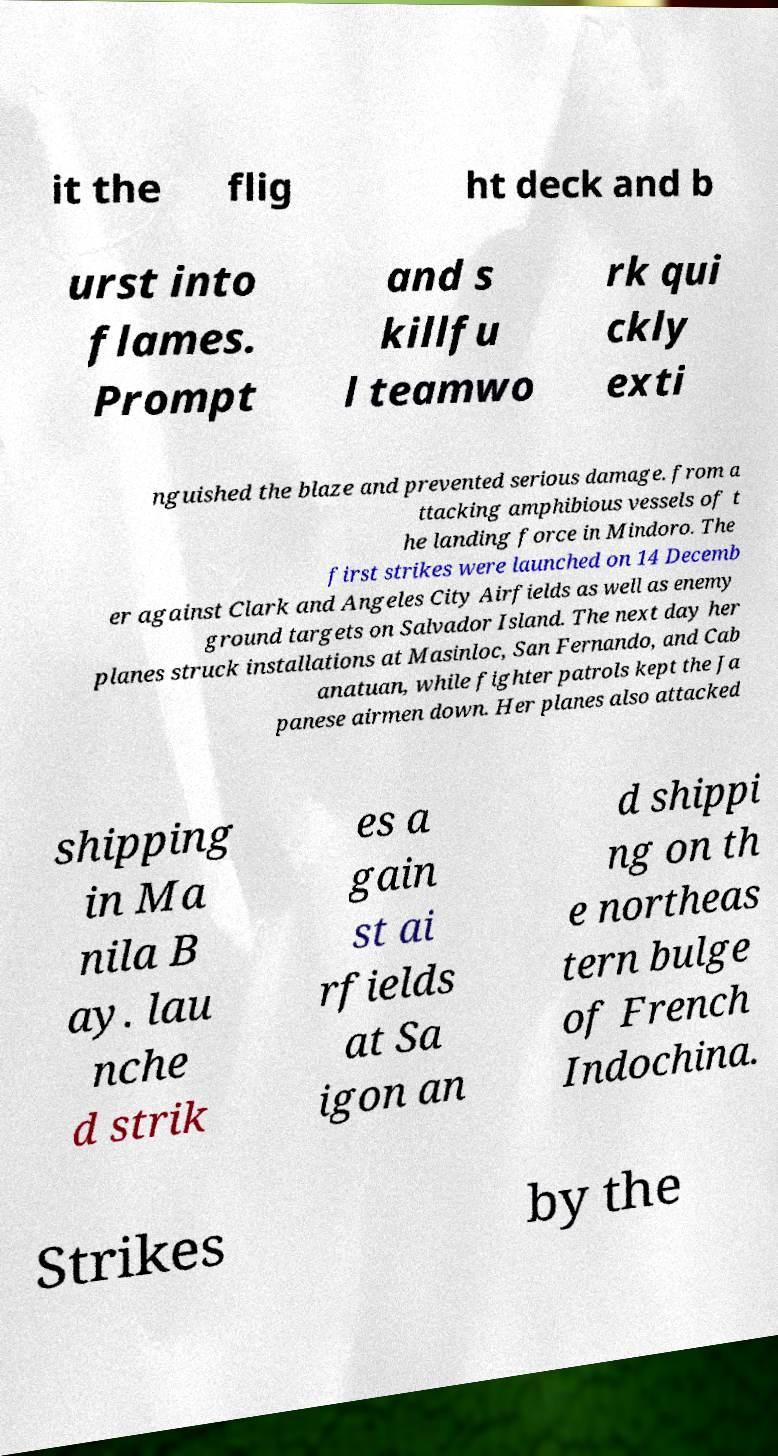I need the written content from this picture converted into text. Can you do that? it the flig ht deck and b urst into flames. Prompt and s killfu l teamwo rk qui ckly exti nguished the blaze and prevented serious damage. from a ttacking amphibious vessels of t he landing force in Mindoro. The first strikes were launched on 14 Decemb er against Clark and Angeles City Airfields as well as enemy ground targets on Salvador Island. The next day her planes struck installations at Masinloc, San Fernando, and Cab anatuan, while fighter patrols kept the Ja panese airmen down. Her planes also attacked shipping in Ma nila B ay. lau nche d strik es a gain st ai rfields at Sa igon an d shippi ng on th e northeas tern bulge of French Indochina. Strikes by the 